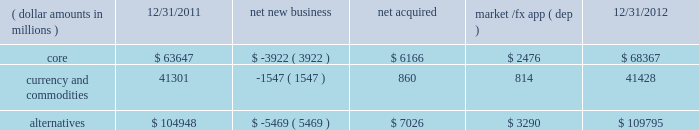Challenging investment environment with $ 15.0 billion , or 95% ( 95 % ) , of net inflows coming from institutional clients , with the remaining $ 0.8 billion , or 5% ( 5 % ) , generated by retail and hnw clients .
Defined contribution plans of institutional clients remained a significant driver of flows .
This client group added $ 13.1 billion of net new business in 2012 .
During the year , americas net inflows of $ 18.5 billion were partially offset by net outflows of $ 2.6 billion collectively from emea and asia-pacific clients .
The company 2019s multi-asset strategies include the following : 2022 asset allocation and balanced products represented 52% ( 52 % ) , or $ 140.2 billion , of multi-asset class aum at year-end , up $ 14.1 billion , with growth in aum driven by net new business of $ 1.6 billion and $ 12.4 billion in market and foreign exchange gains .
These strategies combine equity , fixed income and alternative components for investors seeking a tailored solution relative to a specific benchmark and within a risk budget .
In certain cases , these strategies seek to minimize downside risk through diversification , derivatives strategies and tactical asset allocation decisions .
2022 target date and target risk products ended the year at $ 69.9 billion , up $ 20.8 billion , or 42% ( 42 % ) , since december 31 , 2011 .
Growth in aum was driven by net new business of $ 14.5 billion , a year-over-year organic growth rate of 30% ( 30 % ) .
Institutional investors represented 90% ( 90 % ) of target date and target risk aum , with defined contribution plans accounting for over 80% ( 80 % ) of aum .
The remaining 10% ( 10 % ) of target date and target risk aum consisted of retail client investments .
Flows were driven by defined contribution investments in our lifepath and lifepath retirement income ae offerings , which are qualified investment options under the pension protection act of 2006 .
These products utilize a proprietary asset allocation model that seeks to balance risk and return over an investment horizon based on the investor 2019s expected retirement timing .
2022 fiduciary management services accounted for 22% ( 22 % ) , or $ 57.7 billion , of multi-asset aum at december 31 , 2012 and increased $ 7.7 billion during the year due to market and foreign exchange gains .
These are complex mandates in which pension plan sponsors retain blackrock to assume responsibility for some or all aspects of plan management .
These customized services require strong partnership with the clients 2019 investment staff and trustees in order to tailor investment strategies to meet client-specific risk budgets and return objectives .
Alternatives component changes in alternatives aum ( dollar amounts in millions ) 12/31/2011 net new business acquired market /fx app ( dep ) 12/31/2012 .
Alternatives aum totaled $ 109.8 billion at year-end 2012 , up $ 4.8 billion , or 5% ( 5 % ) , reflecting $ 3.3 billion in portfolio valuation gains and $ 7.0 billion in new assets related to the acquisitions of srpep , which deepened our alternatives footprint in the european and asian markets , and claymore .
Core alternative outflows of $ 3.9 billion were driven almost exclusively by return of capital to clients .
Currency net outflows of $ 5.0 billion were partially offset by net inflows of $ 3.5 billion into ishares commodity funds .
We continued to make significant investments in our alternatives platform as demonstrated by our acquisition of srpep , successful closes on the renewable power initiative and our build out of an alternatives retail platform , which now stands at nearly $ 10.0 billion in aum .
We believe that as alternatives become more conventional and investors adapt their asset allocation strategies to best meet their investment objectives , they will further increase their use of alternative investments to complement core holdings .
Institutional investors represented 69% ( 69 % ) , or $ 75.8 billion , of alternatives aum with retail and hnw investors comprising an additional 9% ( 9 % ) , or $ 9.7 billion , at year-end 2012 .
Ishares commodity products accounted for the remaining $ 24.3 billion , or 22% ( 22 % ) , of aum at year-end .
Alternative clients are geographically diversified with 56% ( 56 % ) , 26% ( 26 % ) , and 18% ( 18 % ) of clients located in the americas , emea and asia-pacific , respectively .
The blackrock alternative investors ( 201cbai 201d ) group coordinates our alternative investment efforts , including .
What is the percentage change in the balance of currency and commodities from 2011 to 2012? 
Computations: ((41428 - 41301) / 41301)
Answer: 0.00307. 